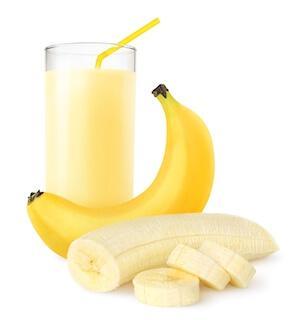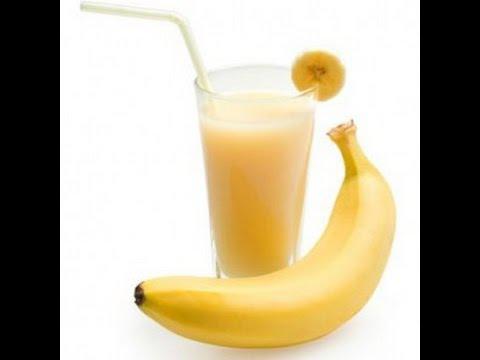The first image is the image on the left, the second image is the image on the right. Analyze the images presented: Is the assertion "Each image includes a creamy drink in a glass with a straw in it, and one image includes a slice of banana as garnish on the rim of the glass." valid? Answer yes or no. Yes. 